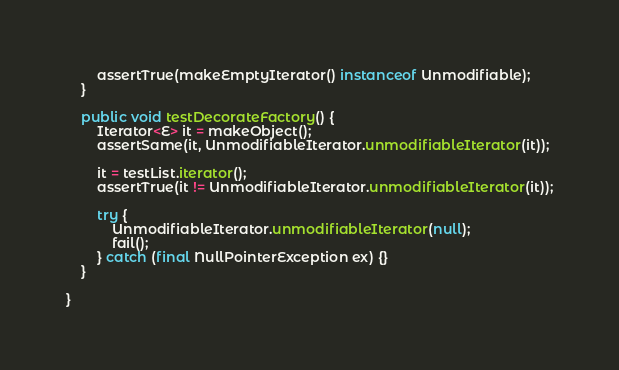<code> <loc_0><loc_0><loc_500><loc_500><_Java_>        assertTrue(makeEmptyIterator() instanceof Unmodifiable);
    }

    public void testDecorateFactory() {
        Iterator<E> it = makeObject();
        assertSame(it, UnmodifiableIterator.unmodifiableIterator(it));

        it = testList.iterator();
        assertTrue(it != UnmodifiableIterator.unmodifiableIterator(it));

        try {
            UnmodifiableIterator.unmodifiableIterator(null);
            fail();
        } catch (final NullPointerException ex) {}
    }

}
</code> 